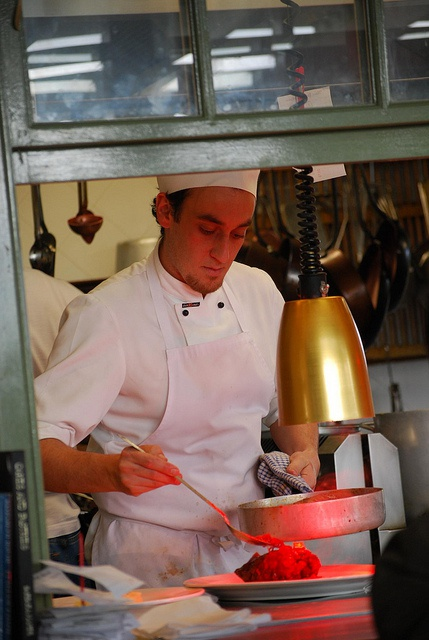Describe the objects in this image and their specific colors. I can see people in black, darkgray, gray, and maroon tones, people in black, tan, and gray tones, and spoon in black, brown, and red tones in this image. 